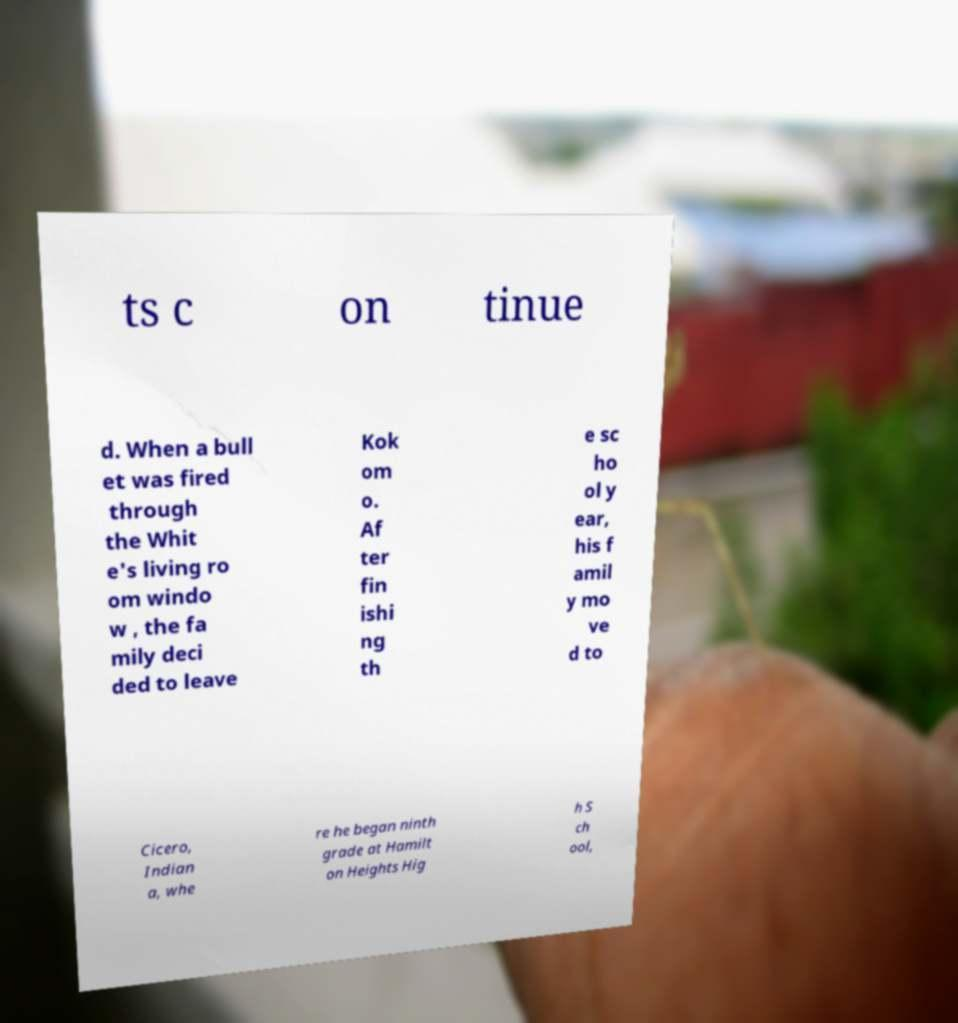Please read and relay the text visible in this image. What does it say? ts c on tinue d. When a bull et was fired through the Whit e's living ro om windo w , the fa mily deci ded to leave Kok om o. Af ter fin ishi ng th e sc ho ol y ear, his f amil y mo ve d to Cicero, Indian a, whe re he began ninth grade at Hamilt on Heights Hig h S ch ool, 